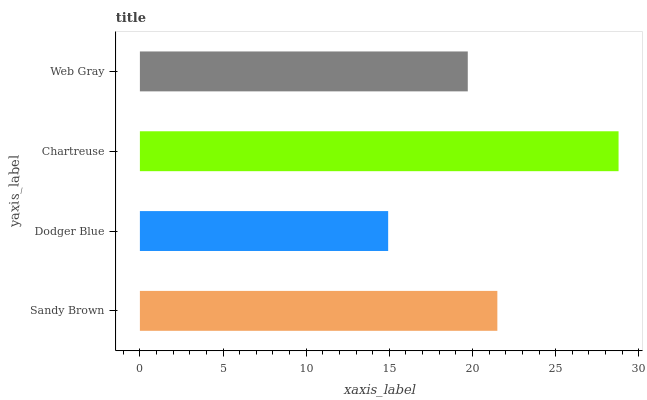Is Dodger Blue the minimum?
Answer yes or no. Yes. Is Chartreuse the maximum?
Answer yes or no. Yes. Is Chartreuse the minimum?
Answer yes or no. No. Is Dodger Blue the maximum?
Answer yes or no. No. Is Chartreuse greater than Dodger Blue?
Answer yes or no. Yes. Is Dodger Blue less than Chartreuse?
Answer yes or no. Yes. Is Dodger Blue greater than Chartreuse?
Answer yes or no. No. Is Chartreuse less than Dodger Blue?
Answer yes or no. No. Is Sandy Brown the high median?
Answer yes or no. Yes. Is Web Gray the low median?
Answer yes or no. Yes. Is Chartreuse the high median?
Answer yes or no. No. Is Sandy Brown the low median?
Answer yes or no. No. 